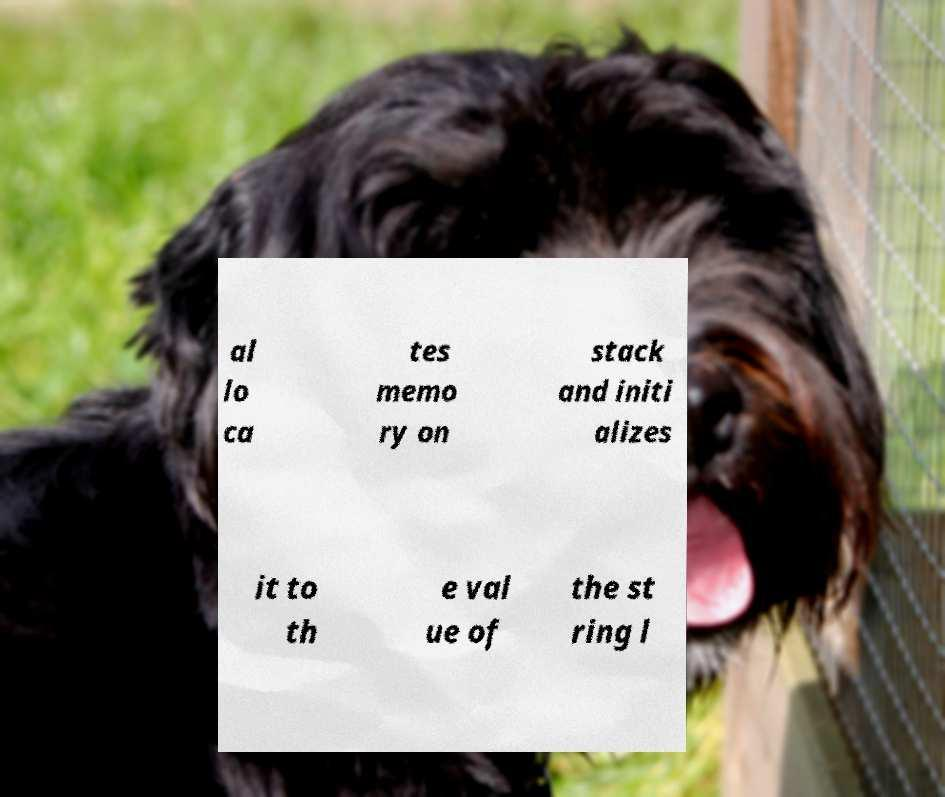I need the written content from this picture converted into text. Can you do that? al lo ca tes memo ry on stack and initi alizes it to th e val ue of the st ring l 